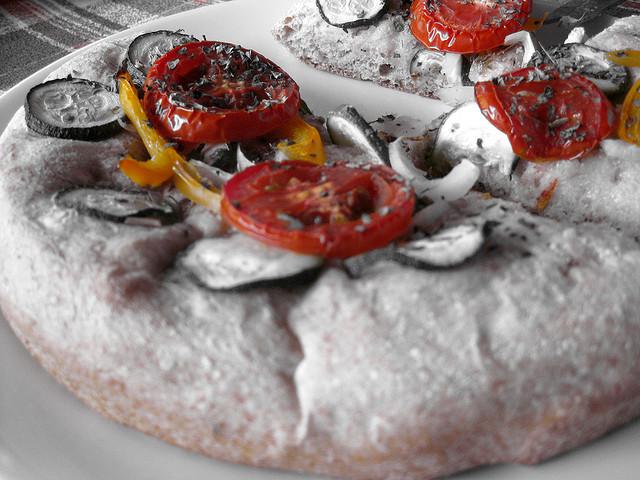What are the red items?
Quick response, please. Tomatoes. Is this seasoned?
Answer briefly. Yes. Is this dessert?
Answer briefly. No. 